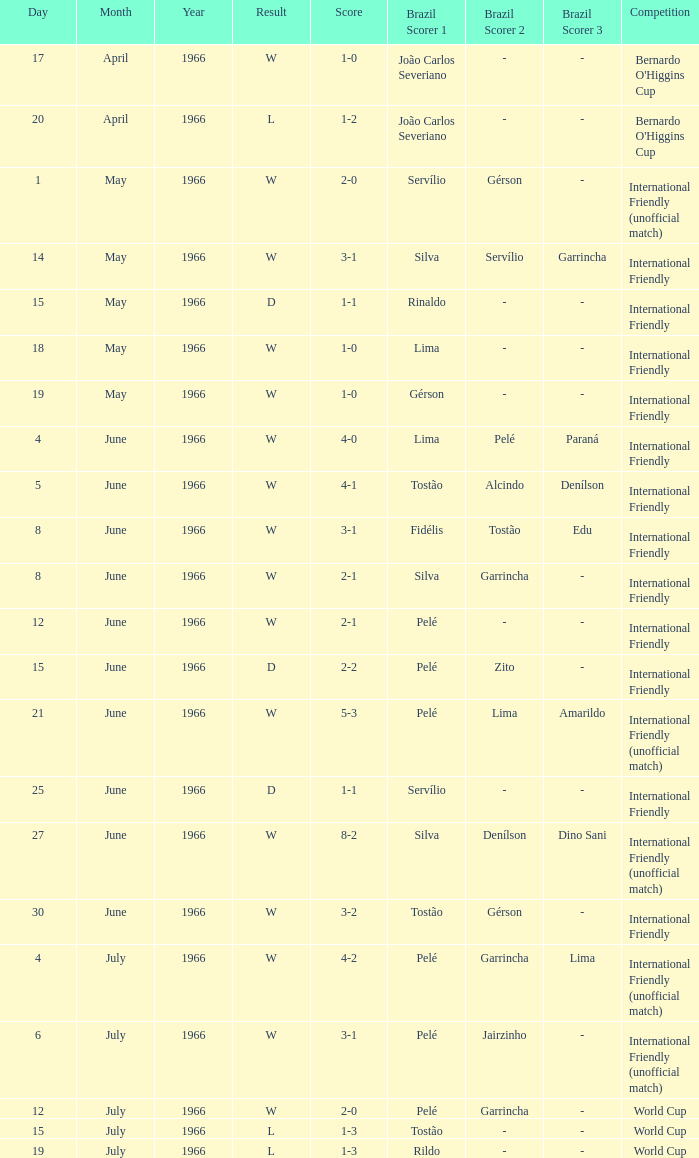What happens when the score is 4-0? W. 